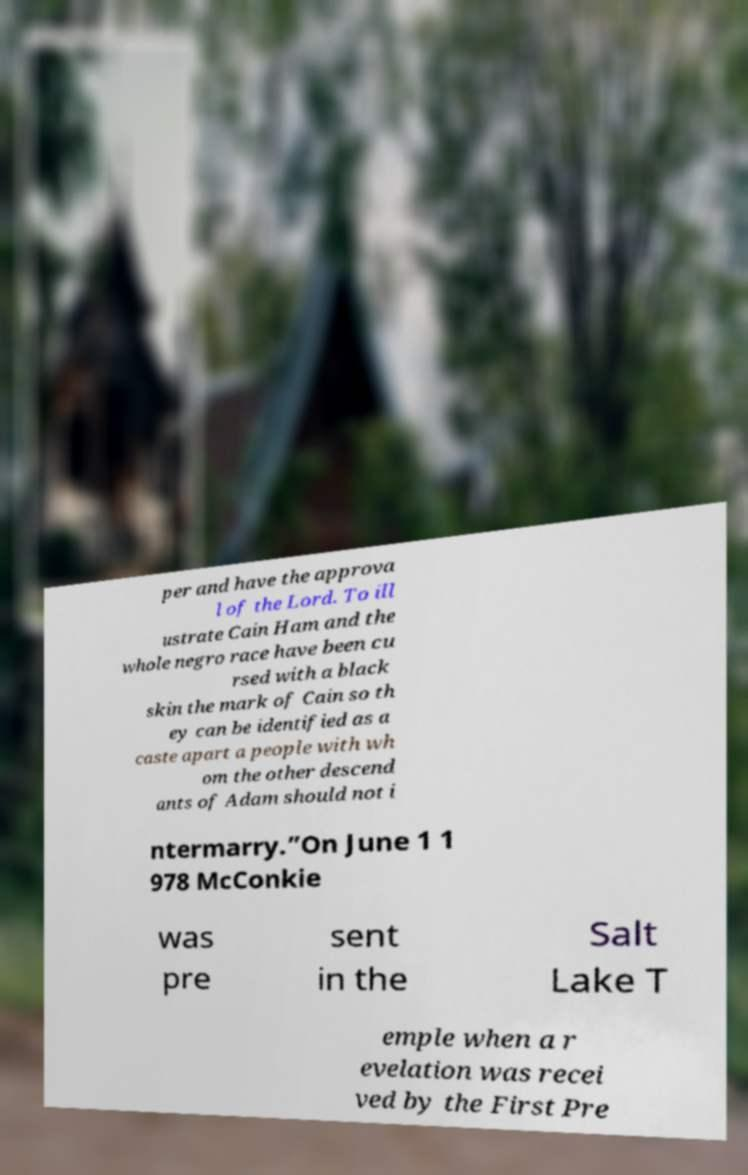I need the written content from this picture converted into text. Can you do that? per and have the approva l of the Lord. To ill ustrate Cain Ham and the whole negro race have been cu rsed with a black skin the mark of Cain so th ey can be identified as a caste apart a people with wh om the other descend ants of Adam should not i ntermarry.”On June 1 1 978 McConkie was pre sent in the Salt Lake T emple when a r evelation was recei ved by the First Pre 